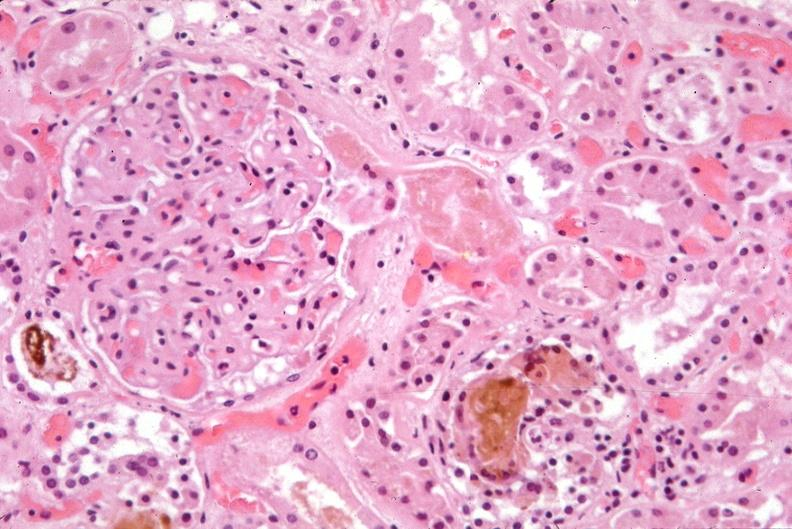does this image show kidney, bile in tubules?
Answer the question using a single word or phrase. Yes 